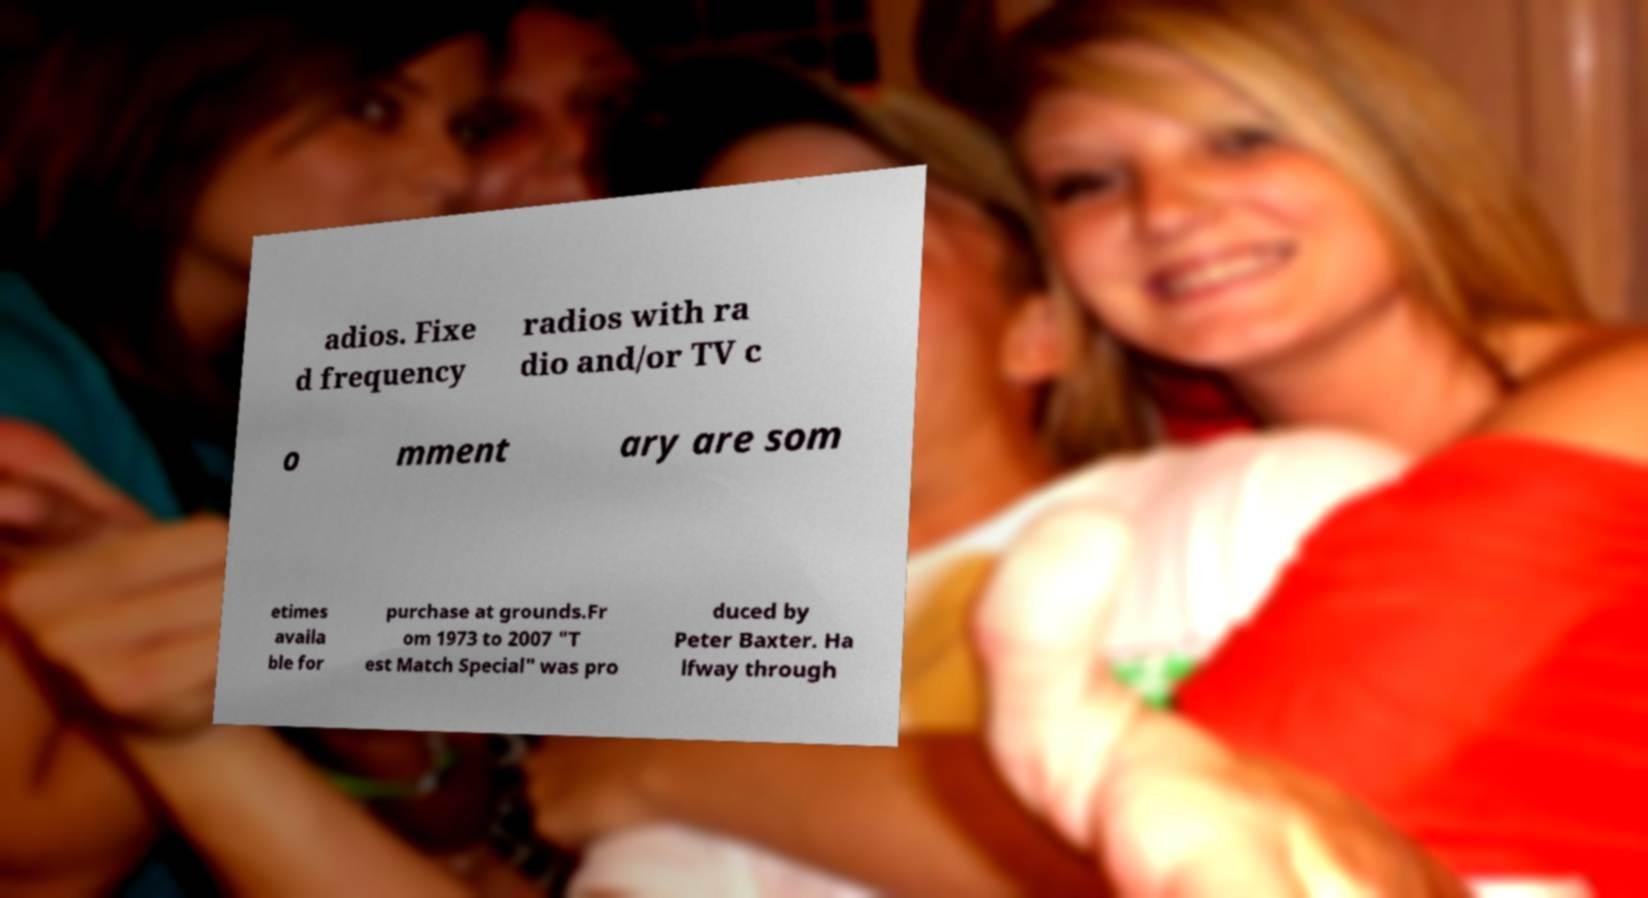What messages or text are displayed in this image? I need them in a readable, typed format. adios. Fixe d frequency radios with ra dio and/or TV c o mment ary are som etimes availa ble for purchase at grounds.Fr om 1973 to 2007 "T est Match Special" was pro duced by Peter Baxter. Ha lfway through 